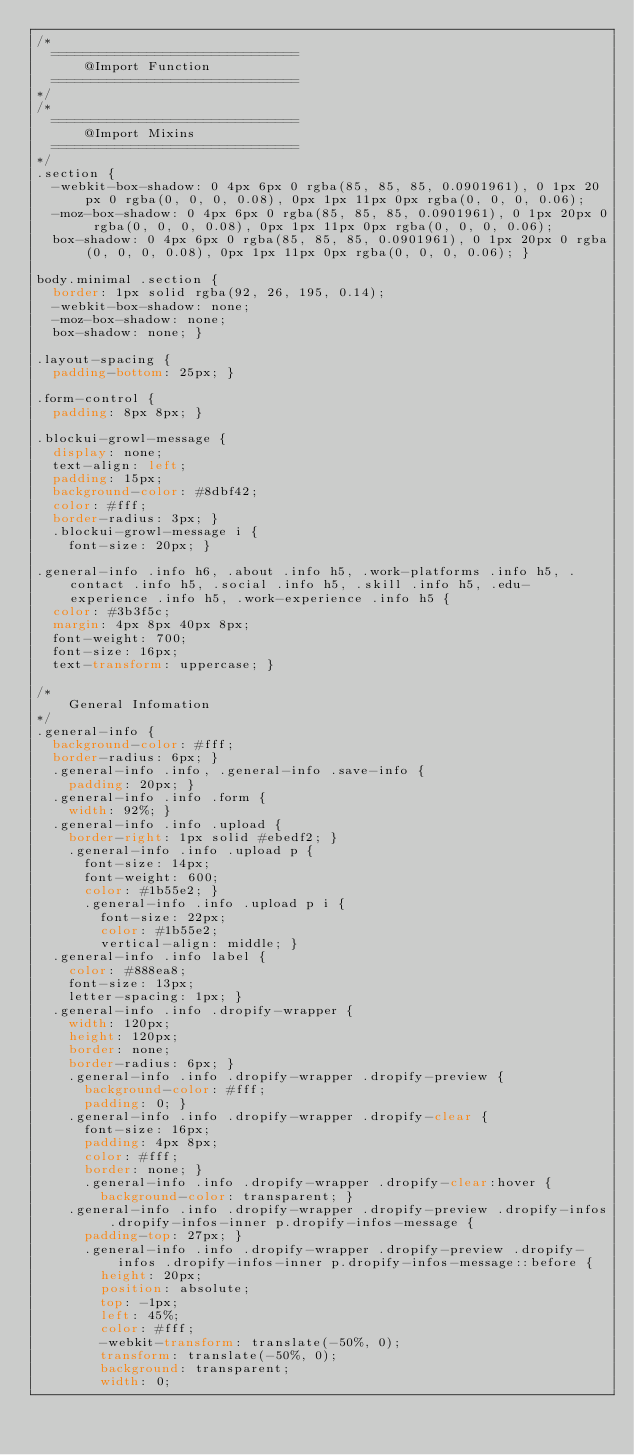Convert code to text. <code><loc_0><loc_0><loc_500><loc_500><_CSS_>/*
	===============================
			@Import	Function
	===============================
*/
/*
	===============================
			@Import	Mixins
	===============================
*/
.section {
  -webkit-box-shadow: 0 4px 6px 0 rgba(85, 85, 85, 0.0901961), 0 1px 20px 0 rgba(0, 0, 0, 0.08), 0px 1px 11px 0px rgba(0, 0, 0, 0.06);
  -moz-box-shadow: 0 4px 6px 0 rgba(85, 85, 85, 0.0901961), 0 1px 20px 0 rgba(0, 0, 0, 0.08), 0px 1px 11px 0px rgba(0, 0, 0, 0.06);
  box-shadow: 0 4px 6px 0 rgba(85, 85, 85, 0.0901961), 0 1px 20px 0 rgba(0, 0, 0, 0.08), 0px 1px 11px 0px rgba(0, 0, 0, 0.06); }

body.minimal .section {
  border: 1px solid rgba(92, 26, 195, 0.14);
  -webkit-box-shadow: none;
  -moz-box-shadow: none;
  box-shadow: none; }

.layout-spacing {
  padding-bottom: 25px; }

.form-control {
  padding: 8px 8px; }

.blockui-growl-message {
  display: none;
  text-align: left;
  padding: 15px;
  background-color: #8dbf42;
  color: #fff;
  border-radius: 3px; }
  .blockui-growl-message i {
    font-size: 20px; }

.general-info .info h6, .about .info h5, .work-platforms .info h5, .contact .info h5, .social .info h5, .skill .info h5, .edu-experience .info h5, .work-experience .info h5 {
  color: #3b3f5c;
  margin: 4px 8px 40px 8px;
  font-weight: 700;
  font-size: 16px;
  text-transform: uppercase; }

/*
    General Infomation
*/
.general-info {
  background-color: #fff;
  border-radius: 6px; }
  .general-info .info, .general-info .save-info {
    padding: 20px; }
  .general-info .info .form {
    width: 92%; }
  .general-info .info .upload {
    border-right: 1px solid #ebedf2; }
    .general-info .info .upload p {
      font-size: 14px;
      font-weight: 600;
      color: #1b55e2; }
      .general-info .info .upload p i {
        font-size: 22px;
        color: #1b55e2;
        vertical-align: middle; }
  .general-info .info label {
    color: #888ea8;
    font-size: 13px;
    letter-spacing: 1px; }
  .general-info .info .dropify-wrapper {
    width: 120px;
    height: 120px;
    border: none;
    border-radius: 6px; }
    .general-info .info .dropify-wrapper .dropify-preview {
      background-color: #fff;
      padding: 0; }
    .general-info .info .dropify-wrapper .dropify-clear {
      font-size: 16px;
      padding: 4px 8px;
      color: #fff;
      border: none; }
      .general-info .info .dropify-wrapper .dropify-clear:hover {
        background-color: transparent; }
    .general-info .info .dropify-wrapper .dropify-preview .dropify-infos .dropify-infos-inner p.dropify-infos-message {
      padding-top: 27px; }
      .general-info .info .dropify-wrapper .dropify-preview .dropify-infos .dropify-infos-inner p.dropify-infos-message::before {
        height: 20px;
        position: absolute;
        top: -1px;
        left: 45%;
        color: #fff;
        -webkit-transform: translate(-50%, 0);
        transform: translate(-50%, 0);
        background: transparent;
        width: 0;</code> 